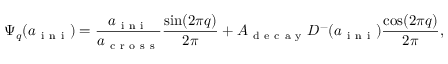Convert formula to latex. <formula><loc_0><loc_0><loc_500><loc_500>\Psi _ { q } ( a _ { i n i } ) = \frac { a _ { i n i } } { a _ { c r o s s } } \frac { \sin ( 2 \pi q ) } { 2 \pi } + A _ { d e c a y } D ^ { - } ( a _ { i n i } ) \frac { \cos ( 2 \pi q ) } { 2 \pi } ,</formula> 